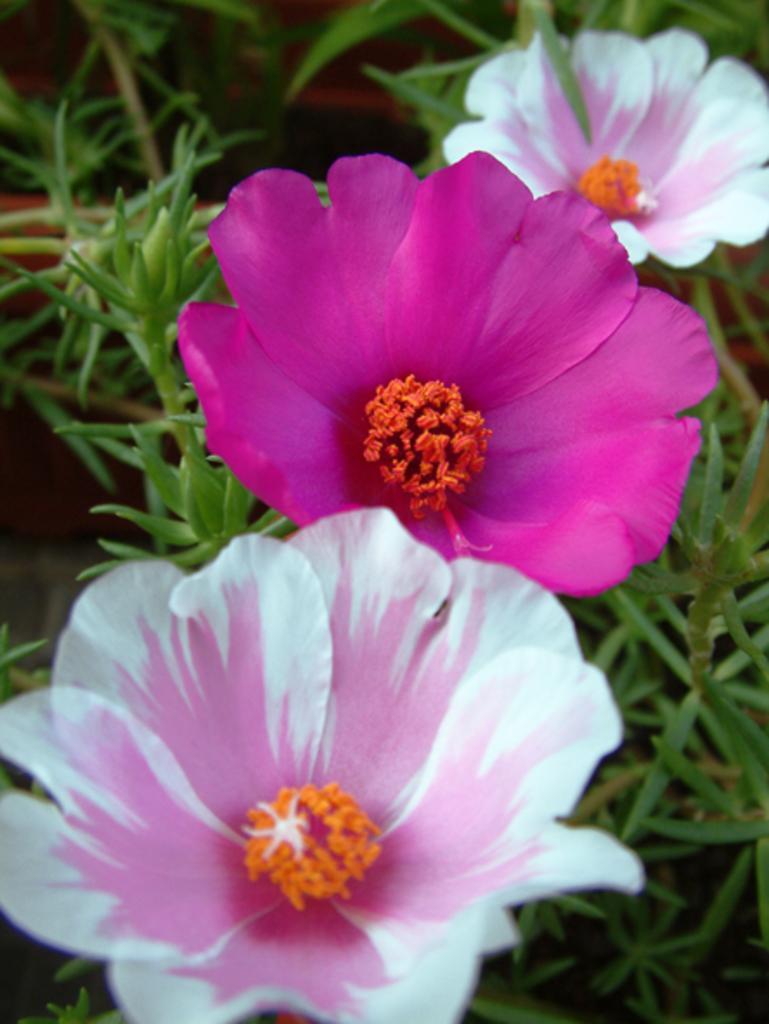How would you summarize this image in a sentence or two? In this image I can see few pink and white colour flowers. I can also see orange colour buds and green colour leaves. I can see this image is little bit blurry from background. 